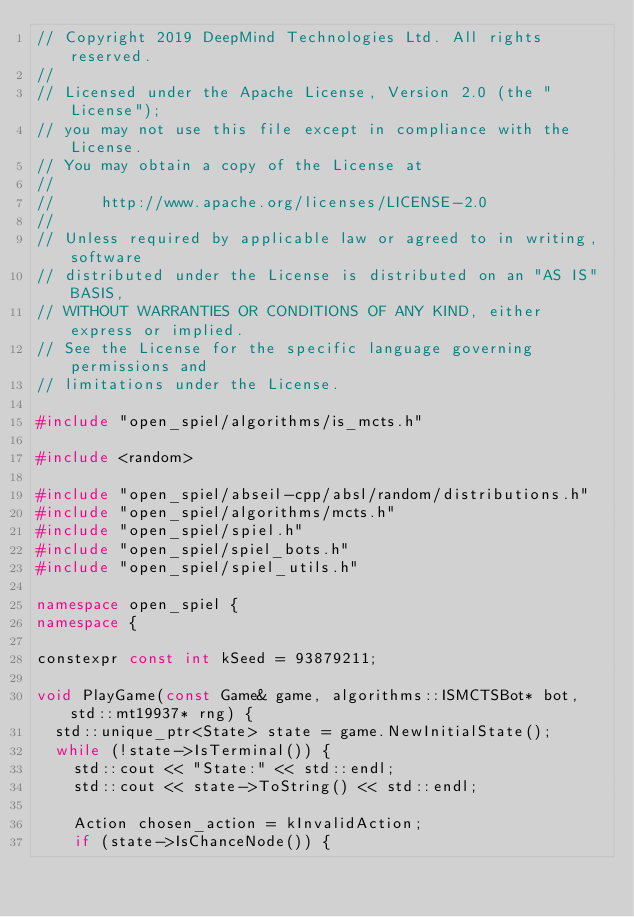<code> <loc_0><loc_0><loc_500><loc_500><_C++_>// Copyright 2019 DeepMind Technologies Ltd. All rights reserved.
//
// Licensed under the Apache License, Version 2.0 (the "License");
// you may not use this file except in compliance with the License.
// You may obtain a copy of the License at
//
//     http://www.apache.org/licenses/LICENSE-2.0
//
// Unless required by applicable law or agreed to in writing, software
// distributed under the License is distributed on an "AS IS" BASIS,
// WITHOUT WARRANTIES OR CONDITIONS OF ANY KIND, either express or implied.
// See the License for the specific language governing permissions and
// limitations under the License.

#include "open_spiel/algorithms/is_mcts.h"

#include <random>

#include "open_spiel/abseil-cpp/absl/random/distributions.h"
#include "open_spiel/algorithms/mcts.h"
#include "open_spiel/spiel.h"
#include "open_spiel/spiel_bots.h"
#include "open_spiel/spiel_utils.h"

namespace open_spiel {
namespace {

constexpr const int kSeed = 93879211;

void PlayGame(const Game& game, algorithms::ISMCTSBot* bot, std::mt19937* rng) {
  std::unique_ptr<State> state = game.NewInitialState();
  while (!state->IsTerminal()) {
    std::cout << "State:" << std::endl;
    std::cout << state->ToString() << std::endl;

    Action chosen_action = kInvalidAction;
    if (state->IsChanceNode()) {</code> 